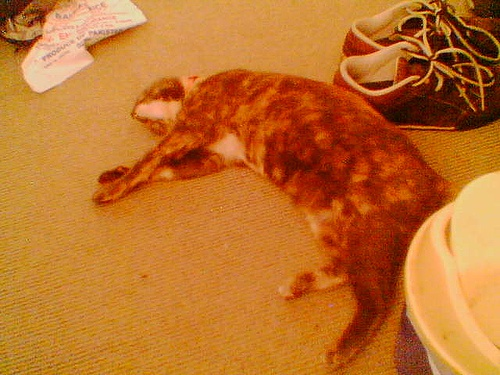Describe the objects in this image and their specific colors. I can see a cat in maroon and red tones in this image. 